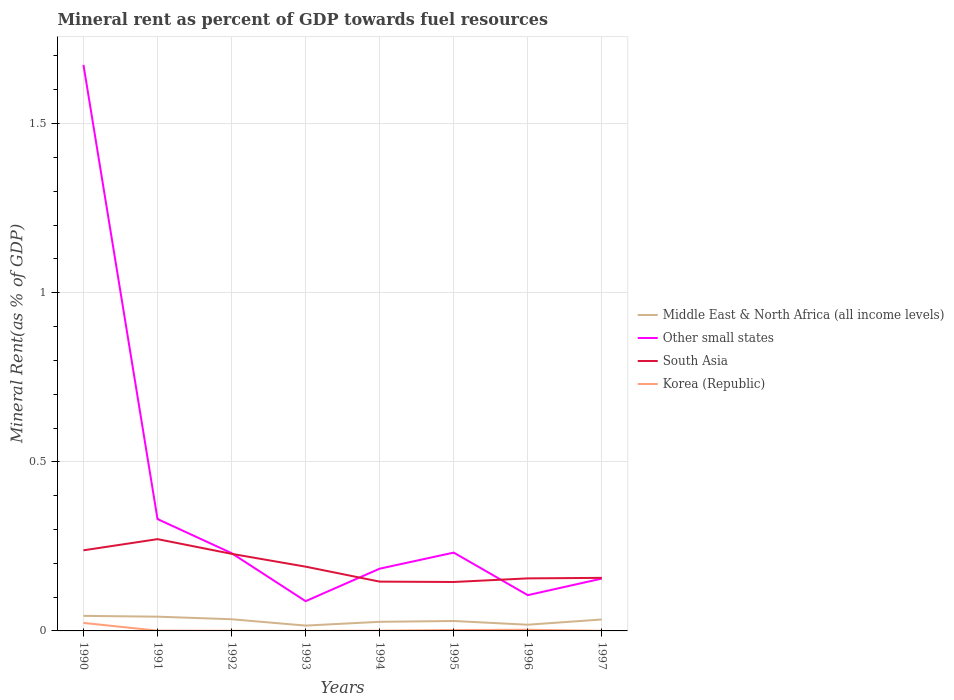Does the line corresponding to Korea (Republic) intersect with the line corresponding to Other small states?
Give a very brief answer. No. Across all years, what is the maximum mineral rent in Other small states?
Offer a very short reply. 0.09. What is the total mineral rent in South Asia in the graph?
Your response must be concise. 0.04. What is the difference between the highest and the second highest mineral rent in Korea (Republic)?
Ensure brevity in your answer.  0.02. What is the difference between the highest and the lowest mineral rent in South Asia?
Give a very brief answer. 3. Does the graph contain grids?
Give a very brief answer. Yes. How are the legend labels stacked?
Give a very brief answer. Vertical. What is the title of the graph?
Your response must be concise. Mineral rent as percent of GDP towards fuel resources. Does "European Union" appear as one of the legend labels in the graph?
Your answer should be very brief. No. What is the label or title of the Y-axis?
Provide a succinct answer. Mineral Rent(as % of GDP). What is the Mineral Rent(as % of GDP) in Middle East & North Africa (all income levels) in 1990?
Offer a terse response. 0.04. What is the Mineral Rent(as % of GDP) of Other small states in 1990?
Your response must be concise. 1.67. What is the Mineral Rent(as % of GDP) of South Asia in 1990?
Keep it short and to the point. 0.24. What is the Mineral Rent(as % of GDP) of Korea (Republic) in 1990?
Your answer should be compact. 0.02. What is the Mineral Rent(as % of GDP) of Middle East & North Africa (all income levels) in 1991?
Your answer should be very brief. 0.04. What is the Mineral Rent(as % of GDP) in Other small states in 1991?
Ensure brevity in your answer.  0.33. What is the Mineral Rent(as % of GDP) of South Asia in 1991?
Make the answer very short. 0.27. What is the Mineral Rent(as % of GDP) in Korea (Republic) in 1991?
Ensure brevity in your answer.  0. What is the Mineral Rent(as % of GDP) in Middle East & North Africa (all income levels) in 1992?
Provide a short and direct response. 0.03. What is the Mineral Rent(as % of GDP) in Other small states in 1992?
Your response must be concise. 0.23. What is the Mineral Rent(as % of GDP) of South Asia in 1992?
Provide a short and direct response. 0.23. What is the Mineral Rent(as % of GDP) in Korea (Republic) in 1992?
Give a very brief answer. 0. What is the Mineral Rent(as % of GDP) in Middle East & North Africa (all income levels) in 1993?
Your response must be concise. 0.02. What is the Mineral Rent(as % of GDP) in Other small states in 1993?
Provide a short and direct response. 0.09. What is the Mineral Rent(as % of GDP) in South Asia in 1993?
Make the answer very short. 0.19. What is the Mineral Rent(as % of GDP) of Korea (Republic) in 1993?
Ensure brevity in your answer.  0. What is the Mineral Rent(as % of GDP) in Middle East & North Africa (all income levels) in 1994?
Keep it short and to the point. 0.03. What is the Mineral Rent(as % of GDP) in Other small states in 1994?
Provide a short and direct response. 0.18. What is the Mineral Rent(as % of GDP) in South Asia in 1994?
Provide a succinct answer. 0.15. What is the Mineral Rent(as % of GDP) in Korea (Republic) in 1994?
Provide a short and direct response. 0. What is the Mineral Rent(as % of GDP) in Middle East & North Africa (all income levels) in 1995?
Ensure brevity in your answer.  0.03. What is the Mineral Rent(as % of GDP) in Other small states in 1995?
Your answer should be compact. 0.23. What is the Mineral Rent(as % of GDP) of South Asia in 1995?
Make the answer very short. 0.14. What is the Mineral Rent(as % of GDP) of Korea (Republic) in 1995?
Provide a succinct answer. 0. What is the Mineral Rent(as % of GDP) in Middle East & North Africa (all income levels) in 1996?
Your response must be concise. 0.02. What is the Mineral Rent(as % of GDP) of Other small states in 1996?
Offer a terse response. 0.11. What is the Mineral Rent(as % of GDP) in South Asia in 1996?
Your answer should be very brief. 0.16. What is the Mineral Rent(as % of GDP) in Korea (Republic) in 1996?
Ensure brevity in your answer.  0. What is the Mineral Rent(as % of GDP) of Middle East & North Africa (all income levels) in 1997?
Your response must be concise. 0.03. What is the Mineral Rent(as % of GDP) in Other small states in 1997?
Offer a very short reply. 0.15. What is the Mineral Rent(as % of GDP) in South Asia in 1997?
Keep it short and to the point. 0.16. What is the Mineral Rent(as % of GDP) of Korea (Republic) in 1997?
Your answer should be very brief. 0. Across all years, what is the maximum Mineral Rent(as % of GDP) of Middle East & North Africa (all income levels)?
Keep it short and to the point. 0.04. Across all years, what is the maximum Mineral Rent(as % of GDP) in Other small states?
Your response must be concise. 1.67. Across all years, what is the maximum Mineral Rent(as % of GDP) in South Asia?
Your response must be concise. 0.27. Across all years, what is the maximum Mineral Rent(as % of GDP) in Korea (Republic)?
Offer a terse response. 0.02. Across all years, what is the minimum Mineral Rent(as % of GDP) of Middle East & North Africa (all income levels)?
Your response must be concise. 0.02. Across all years, what is the minimum Mineral Rent(as % of GDP) in Other small states?
Provide a short and direct response. 0.09. Across all years, what is the minimum Mineral Rent(as % of GDP) in South Asia?
Make the answer very short. 0.14. Across all years, what is the minimum Mineral Rent(as % of GDP) in Korea (Republic)?
Provide a short and direct response. 0. What is the total Mineral Rent(as % of GDP) in Middle East & North Africa (all income levels) in the graph?
Offer a terse response. 0.25. What is the total Mineral Rent(as % of GDP) of Other small states in the graph?
Make the answer very short. 3. What is the total Mineral Rent(as % of GDP) in South Asia in the graph?
Give a very brief answer. 1.53. What is the total Mineral Rent(as % of GDP) of Korea (Republic) in the graph?
Your answer should be very brief. 0.03. What is the difference between the Mineral Rent(as % of GDP) of Middle East & North Africa (all income levels) in 1990 and that in 1991?
Ensure brevity in your answer.  0. What is the difference between the Mineral Rent(as % of GDP) in Other small states in 1990 and that in 1991?
Make the answer very short. 1.34. What is the difference between the Mineral Rent(as % of GDP) of South Asia in 1990 and that in 1991?
Your response must be concise. -0.03. What is the difference between the Mineral Rent(as % of GDP) of Korea (Republic) in 1990 and that in 1991?
Ensure brevity in your answer.  0.02. What is the difference between the Mineral Rent(as % of GDP) of Other small states in 1990 and that in 1992?
Offer a very short reply. 1.44. What is the difference between the Mineral Rent(as % of GDP) in South Asia in 1990 and that in 1992?
Your response must be concise. 0.01. What is the difference between the Mineral Rent(as % of GDP) in Korea (Republic) in 1990 and that in 1992?
Offer a terse response. 0.02. What is the difference between the Mineral Rent(as % of GDP) of Middle East & North Africa (all income levels) in 1990 and that in 1993?
Give a very brief answer. 0.03. What is the difference between the Mineral Rent(as % of GDP) in Other small states in 1990 and that in 1993?
Provide a short and direct response. 1.59. What is the difference between the Mineral Rent(as % of GDP) of South Asia in 1990 and that in 1993?
Provide a succinct answer. 0.05. What is the difference between the Mineral Rent(as % of GDP) in Korea (Republic) in 1990 and that in 1993?
Make the answer very short. 0.02. What is the difference between the Mineral Rent(as % of GDP) of Middle East & North Africa (all income levels) in 1990 and that in 1994?
Offer a very short reply. 0.02. What is the difference between the Mineral Rent(as % of GDP) of Other small states in 1990 and that in 1994?
Provide a short and direct response. 1.49. What is the difference between the Mineral Rent(as % of GDP) of South Asia in 1990 and that in 1994?
Offer a terse response. 0.09. What is the difference between the Mineral Rent(as % of GDP) in Korea (Republic) in 1990 and that in 1994?
Make the answer very short. 0.02. What is the difference between the Mineral Rent(as % of GDP) of Middle East & North Africa (all income levels) in 1990 and that in 1995?
Ensure brevity in your answer.  0.02. What is the difference between the Mineral Rent(as % of GDP) of Other small states in 1990 and that in 1995?
Your answer should be compact. 1.44. What is the difference between the Mineral Rent(as % of GDP) in South Asia in 1990 and that in 1995?
Your answer should be compact. 0.09. What is the difference between the Mineral Rent(as % of GDP) in Korea (Republic) in 1990 and that in 1995?
Provide a short and direct response. 0.02. What is the difference between the Mineral Rent(as % of GDP) of Middle East & North Africa (all income levels) in 1990 and that in 1996?
Your answer should be compact. 0.03. What is the difference between the Mineral Rent(as % of GDP) of Other small states in 1990 and that in 1996?
Your answer should be compact. 1.57. What is the difference between the Mineral Rent(as % of GDP) in South Asia in 1990 and that in 1996?
Make the answer very short. 0.08. What is the difference between the Mineral Rent(as % of GDP) in Korea (Republic) in 1990 and that in 1996?
Provide a short and direct response. 0.02. What is the difference between the Mineral Rent(as % of GDP) in Middle East & North Africa (all income levels) in 1990 and that in 1997?
Make the answer very short. 0.01. What is the difference between the Mineral Rent(as % of GDP) of Other small states in 1990 and that in 1997?
Give a very brief answer. 1.52. What is the difference between the Mineral Rent(as % of GDP) of South Asia in 1990 and that in 1997?
Your answer should be very brief. 0.08. What is the difference between the Mineral Rent(as % of GDP) of Korea (Republic) in 1990 and that in 1997?
Your response must be concise. 0.02. What is the difference between the Mineral Rent(as % of GDP) of Middle East & North Africa (all income levels) in 1991 and that in 1992?
Provide a short and direct response. 0.01. What is the difference between the Mineral Rent(as % of GDP) in Other small states in 1991 and that in 1992?
Offer a terse response. 0.1. What is the difference between the Mineral Rent(as % of GDP) of South Asia in 1991 and that in 1992?
Offer a terse response. 0.04. What is the difference between the Mineral Rent(as % of GDP) of Middle East & North Africa (all income levels) in 1991 and that in 1993?
Offer a terse response. 0.03. What is the difference between the Mineral Rent(as % of GDP) of Other small states in 1991 and that in 1993?
Your response must be concise. 0.24. What is the difference between the Mineral Rent(as % of GDP) of South Asia in 1991 and that in 1993?
Your answer should be very brief. 0.08. What is the difference between the Mineral Rent(as % of GDP) of Korea (Republic) in 1991 and that in 1993?
Your response must be concise. 0. What is the difference between the Mineral Rent(as % of GDP) in Middle East & North Africa (all income levels) in 1991 and that in 1994?
Give a very brief answer. 0.02. What is the difference between the Mineral Rent(as % of GDP) in Other small states in 1991 and that in 1994?
Your answer should be compact. 0.15. What is the difference between the Mineral Rent(as % of GDP) in South Asia in 1991 and that in 1994?
Offer a terse response. 0.13. What is the difference between the Mineral Rent(as % of GDP) in Middle East & North Africa (all income levels) in 1991 and that in 1995?
Keep it short and to the point. 0.01. What is the difference between the Mineral Rent(as % of GDP) in Other small states in 1991 and that in 1995?
Your answer should be compact. 0.1. What is the difference between the Mineral Rent(as % of GDP) in South Asia in 1991 and that in 1995?
Your answer should be compact. 0.13. What is the difference between the Mineral Rent(as % of GDP) of Korea (Republic) in 1991 and that in 1995?
Your answer should be very brief. -0. What is the difference between the Mineral Rent(as % of GDP) of Middle East & North Africa (all income levels) in 1991 and that in 1996?
Give a very brief answer. 0.02. What is the difference between the Mineral Rent(as % of GDP) in Other small states in 1991 and that in 1996?
Offer a very short reply. 0.23. What is the difference between the Mineral Rent(as % of GDP) of South Asia in 1991 and that in 1996?
Give a very brief answer. 0.12. What is the difference between the Mineral Rent(as % of GDP) in Korea (Republic) in 1991 and that in 1996?
Provide a succinct answer. -0. What is the difference between the Mineral Rent(as % of GDP) in Middle East & North Africa (all income levels) in 1991 and that in 1997?
Keep it short and to the point. 0.01. What is the difference between the Mineral Rent(as % of GDP) in Other small states in 1991 and that in 1997?
Your answer should be very brief. 0.18. What is the difference between the Mineral Rent(as % of GDP) in South Asia in 1991 and that in 1997?
Provide a short and direct response. 0.11. What is the difference between the Mineral Rent(as % of GDP) in Korea (Republic) in 1991 and that in 1997?
Your response must be concise. 0. What is the difference between the Mineral Rent(as % of GDP) of Middle East & North Africa (all income levels) in 1992 and that in 1993?
Give a very brief answer. 0.02. What is the difference between the Mineral Rent(as % of GDP) of Other small states in 1992 and that in 1993?
Offer a terse response. 0.14. What is the difference between the Mineral Rent(as % of GDP) of South Asia in 1992 and that in 1993?
Your response must be concise. 0.04. What is the difference between the Mineral Rent(as % of GDP) of Middle East & North Africa (all income levels) in 1992 and that in 1994?
Make the answer very short. 0.01. What is the difference between the Mineral Rent(as % of GDP) in Other small states in 1992 and that in 1994?
Your answer should be compact. 0.05. What is the difference between the Mineral Rent(as % of GDP) of South Asia in 1992 and that in 1994?
Your answer should be very brief. 0.08. What is the difference between the Mineral Rent(as % of GDP) in Korea (Republic) in 1992 and that in 1994?
Your response must be concise. -0. What is the difference between the Mineral Rent(as % of GDP) in Middle East & North Africa (all income levels) in 1992 and that in 1995?
Give a very brief answer. 0.01. What is the difference between the Mineral Rent(as % of GDP) in Other small states in 1992 and that in 1995?
Give a very brief answer. -0. What is the difference between the Mineral Rent(as % of GDP) in South Asia in 1992 and that in 1995?
Make the answer very short. 0.08. What is the difference between the Mineral Rent(as % of GDP) in Korea (Republic) in 1992 and that in 1995?
Offer a terse response. -0. What is the difference between the Mineral Rent(as % of GDP) in Middle East & North Africa (all income levels) in 1992 and that in 1996?
Give a very brief answer. 0.02. What is the difference between the Mineral Rent(as % of GDP) of Other small states in 1992 and that in 1996?
Provide a succinct answer. 0.12. What is the difference between the Mineral Rent(as % of GDP) in South Asia in 1992 and that in 1996?
Provide a short and direct response. 0.07. What is the difference between the Mineral Rent(as % of GDP) of Korea (Republic) in 1992 and that in 1996?
Ensure brevity in your answer.  -0. What is the difference between the Mineral Rent(as % of GDP) in Middle East & North Africa (all income levels) in 1992 and that in 1997?
Make the answer very short. 0. What is the difference between the Mineral Rent(as % of GDP) in Other small states in 1992 and that in 1997?
Provide a succinct answer. 0.08. What is the difference between the Mineral Rent(as % of GDP) in South Asia in 1992 and that in 1997?
Provide a short and direct response. 0.07. What is the difference between the Mineral Rent(as % of GDP) in Korea (Republic) in 1992 and that in 1997?
Keep it short and to the point. 0. What is the difference between the Mineral Rent(as % of GDP) in Middle East & North Africa (all income levels) in 1993 and that in 1994?
Provide a short and direct response. -0.01. What is the difference between the Mineral Rent(as % of GDP) of Other small states in 1993 and that in 1994?
Your answer should be very brief. -0.1. What is the difference between the Mineral Rent(as % of GDP) in South Asia in 1993 and that in 1994?
Provide a short and direct response. 0.04. What is the difference between the Mineral Rent(as % of GDP) in Korea (Republic) in 1993 and that in 1994?
Make the answer very short. -0. What is the difference between the Mineral Rent(as % of GDP) of Middle East & North Africa (all income levels) in 1993 and that in 1995?
Your answer should be compact. -0.01. What is the difference between the Mineral Rent(as % of GDP) in Other small states in 1993 and that in 1995?
Offer a terse response. -0.14. What is the difference between the Mineral Rent(as % of GDP) in South Asia in 1993 and that in 1995?
Give a very brief answer. 0.05. What is the difference between the Mineral Rent(as % of GDP) in Korea (Republic) in 1993 and that in 1995?
Offer a terse response. -0. What is the difference between the Mineral Rent(as % of GDP) in Middle East & North Africa (all income levels) in 1993 and that in 1996?
Offer a very short reply. -0. What is the difference between the Mineral Rent(as % of GDP) in Other small states in 1993 and that in 1996?
Your answer should be compact. -0.02. What is the difference between the Mineral Rent(as % of GDP) of South Asia in 1993 and that in 1996?
Keep it short and to the point. 0.03. What is the difference between the Mineral Rent(as % of GDP) in Korea (Republic) in 1993 and that in 1996?
Provide a short and direct response. -0. What is the difference between the Mineral Rent(as % of GDP) in Middle East & North Africa (all income levels) in 1993 and that in 1997?
Make the answer very short. -0.02. What is the difference between the Mineral Rent(as % of GDP) of Other small states in 1993 and that in 1997?
Keep it short and to the point. -0.07. What is the difference between the Mineral Rent(as % of GDP) in South Asia in 1993 and that in 1997?
Offer a terse response. 0.03. What is the difference between the Mineral Rent(as % of GDP) of Korea (Republic) in 1993 and that in 1997?
Give a very brief answer. -0. What is the difference between the Mineral Rent(as % of GDP) of Middle East & North Africa (all income levels) in 1994 and that in 1995?
Offer a very short reply. -0. What is the difference between the Mineral Rent(as % of GDP) in Other small states in 1994 and that in 1995?
Make the answer very short. -0.05. What is the difference between the Mineral Rent(as % of GDP) in South Asia in 1994 and that in 1995?
Offer a terse response. 0. What is the difference between the Mineral Rent(as % of GDP) in Korea (Republic) in 1994 and that in 1995?
Offer a terse response. -0. What is the difference between the Mineral Rent(as % of GDP) of Middle East & North Africa (all income levels) in 1994 and that in 1996?
Ensure brevity in your answer.  0.01. What is the difference between the Mineral Rent(as % of GDP) of Other small states in 1994 and that in 1996?
Offer a very short reply. 0.08. What is the difference between the Mineral Rent(as % of GDP) in South Asia in 1994 and that in 1996?
Provide a short and direct response. -0.01. What is the difference between the Mineral Rent(as % of GDP) in Korea (Republic) in 1994 and that in 1996?
Make the answer very short. -0. What is the difference between the Mineral Rent(as % of GDP) of Middle East & North Africa (all income levels) in 1994 and that in 1997?
Make the answer very short. -0.01. What is the difference between the Mineral Rent(as % of GDP) in Other small states in 1994 and that in 1997?
Offer a terse response. 0.03. What is the difference between the Mineral Rent(as % of GDP) of South Asia in 1994 and that in 1997?
Your answer should be very brief. -0.01. What is the difference between the Mineral Rent(as % of GDP) in Korea (Republic) in 1994 and that in 1997?
Offer a terse response. 0. What is the difference between the Mineral Rent(as % of GDP) in Middle East & North Africa (all income levels) in 1995 and that in 1996?
Make the answer very short. 0.01. What is the difference between the Mineral Rent(as % of GDP) in Other small states in 1995 and that in 1996?
Offer a very short reply. 0.13. What is the difference between the Mineral Rent(as % of GDP) in South Asia in 1995 and that in 1996?
Make the answer very short. -0.01. What is the difference between the Mineral Rent(as % of GDP) of Korea (Republic) in 1995 and that in 1996?
Provide a succinct answer. -0. What is the difference between the Mineral Rent(as % of GDP) in Middle East & North Africa (all income levels) in 1995 and that in 1997?
Your answer should be very brief. -0. What is the difference between the Mineral Rent(as % of GDP) in Other small states in 1995 and that in 1997?
Offer a terse response. 0.08. What is the difference between the Mineral Rent(as % of GDP) in South Asia in 1995 and that in 1997?
Your answer should be very brief. -0.01. What is the difference between the Mineral Rent(as % of GDP) in Korea (Republic) in 1995 and that in 1997?
Your response must be concise. 0. What is the difference between the Mineral Rent(as % of GDP) in Middle East & North Africa (all income levels) in 1996 and that in 1997?
Your answer should be very brief. -0.02. What is the difference between the Mineral Rent(as % of GDP) in Other small states in 1996 and that in 1997?
Provide a short and direct response. -0.05. What is the difference between the Mineral Rent(as % of GDP) in South Asia in 1996 and that in 1997?
Provide a succinct answer. -0. What is the difference between the Mineral Rent(as % of GDP) of Korea (Republic) in 1996 and that in 1997?
Your response must be concise. 0. What is the difference between the Mineral Rent(as % of GDP) in Middle East & North Africa (all income levels) in 1990 and the Mineral Rent(as % of GDP) in Other small states in 1991?
Provide a succinct answer. -0.29. What is the difference between the Mineral Rent(as % of GDP) in Middle East & North Africa (all income levels) in 1990 and the Mineral Rent(as % of GDP) in South Asia in 1991?
Your answer should be compact. -0.23. What is the difference between the Mineral Rent(as % of GDP) in Middle East & North Africa (all income levels) in 1990 and the Mineral Rent(as % of GDP) in Korea (Republic) in 1991?
Ensure brevity in your answer.  0.04. What is the difference between the Mineral Rent(as % of GDP) of Other small states in 1990 and the Mineral Rent(as % of GDP) of South Asia in 1991?
Provide a short and direct response. 1.4. What is the difference between the Mineral Rent(as % of GDP) in Other small states in 1990 and the Mineral Rent(as % of GDP) in Korea (Republic) in 1991?
Make the answer very short. 1.67. What is the difference between the Mineral Rent(as % of GDP) in South Asia in 1990 and the Mineral Rent(as % of GDP) in Korea (Republic) in 1991?
Provide a succinct answer. 0.24. What is the difference between the Mineral Rent(as % of GDP) of Middle East & North Africa (all income levels) in 1990 and the Mineral Rent(as % of GDP) of Other small states in 1992?
Give a very brief answer. -0.19. What is the difference between the Mineral Rent(as % of GDP) in Middle East & North Africa (all income levels) in 1990 and the Mineral Rent(as % of GDP) in South Asia in 1992?
Provide a succinct answer. -0.18. What is the difference between the Mineral Rent(as % of GDP) of Middle East & North Africa (all income levels) in 1990 and the Mineral Rent(as % of GDP) of Korea (Republic) in 1992?
Provide a succinct answer. 0.04. What is the difference between the Mineral Rent(as % of GDP) in Other small states in 1990 and the Mineral Rent(as % of GDP) in South Asia in 1992?
Give a very brief answer. 1.45. What is the difference between the Mineral Rent(as % of GDP) of Other small states in 1990 and the Mineral Rent(as % of GDP) of Korea (Republic) in 1992?
Provide a short and direct response. 1.67. What is the difference between the Mineral Rent(as % of GDP) in South Asia in 1990 and the Mineral Rent(as % of GDP) in Korea (Republic) in 1992?
Ensure brevity in your answer.  0.24. What is the difference between the Mineral Rent(as % of GDP) of Middle East & North Africa (all income levels) in 1990 and the Mineral Rent(as % of GDP) of Other small states in 1993?
Offer a terse response. -0.04. What is the difference between the Mineral Rent(as % of GDP) of Middle East & North Africa (all income levels) in 1990 and the Mineral Rent(as % of GDP) of South Asia in 1993?
Your response must be concise. -0.15. What is the difference between the Mineral Rent(as % of GDP) in Middle East & North Africa (all income levels) in 1990 and the Mineral Rent(as % of GDP) in Korea (Republic) in 1993?
Ensure brevity in your answer.  0.04. What is the difference between the Mineral Rent(as % of GDP) of Other small states in 1990 and the Mineral Rent(as % of GDP) of South Asia in 1993?
Your answer should be very brief. 1.48. What is the difference between the Mineral Rent(as % of GDP) in Other small states in 1990 and the Mineral Rent(as % of GDP) in Korea (Republic) in 1993?
Provide a short and direct response. 1.67. What is the difference between the Mineral Rent(as % of GDP) of South Asia in 1990 and the Mineral Rent(as % of GDP) of Korea (Republic) in 1993?
Your answer should be very brief. 0.24. What is the difference between the Mineral Rent(as % of GDP) in Middle East & North Africa (all income levels) in 1990 and the Mineral Rent(as % of GDP) in Other small states in 1994?
Your answer should be compact. -0.14. What is the difference between the Mineral Rent(as % of GDP) of Middle East & North Africa (all income levels) in 1990 and the Mineral Rent(as % of GDP) of South Asia in 1994?
Provide a succinct answer. -0.1. What is the difference between the Mineral Rent(as % of GDP) in Middle East & North Africa (all income levels) in 1990 and the Mineral Rent(as % of GDP) in Korea (Republic) in 1994?
Your answer should be compact. 0.04. What is the difference between the Mineral Rent(as % of GDP) of Other small states in 1990 and the Mineral Rent(as % of GDP) of South Asia in 1994?
Keep it short and to the point. 1.53. What is the difference between the Mineral Rent(as % of GDP) in Other small states in 1990 and the Mineral Rent(as % of GDP) in Korea (Republic) in 1994?
Provide a short and direct response. 1.67. What is the difference between the Mineral Rent(as % of GDP) in South Asia in 1990 and the Mineral Rent(as % of GDP) in Korea (Republic) in 1994?
Keep it short and to the point. 0.24. What is the difference between the Mineral Rent(as % of GDP) of Middle East & North Africa (all income levels) in 1990 and the Mineral Rent(as % of GDP) of Other small states in 1995?
Give a very brief answer. -0.19. What is the difference between the Mineral Rent(as % of GDP) in Middle East & North Africa (all income levels) in 1990 and the Mineral Rent(as % of GDP) in South Asia in 1995?
Provide a succinct answer. -0.1. What is the difference between the Mineral Rent(as % of GDP) of Middle East & North Africa (all income levels) in 1990 and the Mineral Rent(as % of GDP) of Korea (Republic) in 1995?
Offer a terse response. 0.04. What is the difference between the Mineral Rent(as % of GDP) in Other small states in 1990 and the Mineral Rent(as % of GDP) in South Asia in 1995?
Provide a succinct answer. 1.53. What is the difference between the Mineral Rent(as % of GDP) in Other small states in 1990 and the Mineral Rent(as % of GDP) in Korea (Republic) in 1995?
Make the answer very short. 1.67. What is the difference between the Mineral Rent(as % of GDP) in South Asia in 1990 and the Mineral Rent(as % of GDP) in Korea (Republic) in 1995?
Your answer should be very brief. 0.24. What is the difference between the Mineral Rent(as % of GDP) of Middle East & North Africa (all income levels) in 1990 and the Mineral Rent(as % of GDP) of Other small states in 1996?
Provide a succinct answer. -0.06. What is the difference between the Mineral Rent(as % of GDP) of Middle East & North Africa (all income levels) in 1990 and the Mineral Rent(as % of GDP) of South Asia in 1996?
Your answer should be very brief. -0.11. What is the difference between the Mineral Rent(as % of GDP) of Middle East & North Africa (all income levels) in 1990 and the Mineral Rent(as % of GDP) of Korea (Republic) in 1996?
Your answer should be very brief. 0.04. What is the difference between the Mineral Rent(as % of GDP) of Other small states in 1990 and the Mineral Rent(as % of GDP) of South Asia in 1996?
Ensure brevity in your answer.  1.52. What is the difference between the Mineral Rent(as % of GDP) in Other small states in 1990 and the Mineral Rent(as % of GDP) in Korea (Republic) in 1996?
Offer a very short reply. 1.67. What is the difference between the Mineral Rent(as % of GDP) in South Asia in 1990 and the Mineral Rent(as % of GDP) in Korea (Republic) in 1996?
Give a very brief answer. 0.23. What is the difference between the Mineral Rent(as % of GDP) in Middle East & North Africa (all income levels) in 1990 and the Mineral Rent(as % of GDP) in Other small states in 1997?
Your response must be concise. -0.11. What is the difference between the Mineral Rent(as % of GDP) of Middle East & North Africa (all income levels) in 1990 and the Mineral Rent(as % of GDP) of South Asia in 1997?
Offer a very short reply. -0.11. What is the difference between the Mineral Rent(as % of GDP) in Middle East & North Africa (all income levels) in 1990 and the Mineral Rent(as % of GDP) in Korea (Republic) in 1997?
Give a very brief answer. 0.04. What is the difference between the Mineral Rent(as % of GDP) in Other small states in 1990 and the Mineral Rent(as % of GDP) in South Asia in 1997?
Provide a succinct answer. 1.52. What is the difference between the Mineral Rent(as % of GDP) of Other small states in 1990 and the Mineral Rent(as % of GDP) of Korea (Republic) in 1997?
Give a very brief answer. 1.67. What is the difference between the Mineral Rent(as % of GDP) of South Asia in 1990 and the Mineral Rent(as % of GDP) of Korea (Republic) in 1997?
Make the answer very short. 0.24. What is the difference between the Mineral Rent(as % of GDP) of Middle East & North Africa (all income levels) in 1991 and the Mineral Rent(as % of GDP) of Other small states in 1992?
Provide a short and direct response. -0.19. What is the difference between the Mineral Rent(as % of GDP) of Middle East & North Africa (all income levels) in 1991 and the Mineral Rent(as % of GDP) of South Asia in 1992?
Your response must be concise. -0.19. What is the difference between the Mineral Rent(as % of GDP) of Middle East & North Africa (all income levels) in 1991 and the Mineral Rent(as % of GDP) of Korea (Republic) in 1992?
Ensure brevity in your answer.  0.04. What is the difference between the Mineral Rent(as % of GDP) of Other small states in 1991 and the Mineral Rent(as % of GDP) of South Asia in 1992?
Provide a succinct answer. 0.1. What is the difference between the Mineral Rent(as % of GDP) in Other small states in 1991 and the Mineral Rent(as % of GDP) in Korea (Republic) in 1992?
Offer a very short reply. 0.33. What is the difference between the Mineral Rent(as % of GDP) in South Asia in 1991 and the Mineral Rent(as % of GDP) in Korea (Republic) in 1992?
Provide a succinct answer. 0.27. What is the difference between the Mineral Rent(as % of GDP) of Middle East & North Africa (all income levels) in 1991 and the Mineral Rent(as % of GDP) of Other small states in 1993?
Keep it short and to the point. -0.05. What is the difference between the Mineral Rent(as % of GDP) of Middle East & North Africa (all income levels) in 1991 and the Mineral Rent(as % of GDP) of South Asia in 1993?
Provide a short and direct response. -0.15. What is the difference between the Mineral Rent(as % of GDP) in Middle East & North Africa (all income levels) in 1991 and the Mineral Rent(as % of GDP) in Korea (Republic) in 1993?
Offer a very short reply. 0.04. What is the difference between the Mineral Rent(as % of GDP) of Other small states in 1991 and the Mineral Rent(as % of GDP) of South Asia in 1993?
Give a very brief answer. 0.14. What is the difference between the Mineral Rent(as % of GDP) in Other small states in 1991 and the Mineral Rent(as % of GDP) in Korea (Republic) in 1993?
Your answer should be very brief. 0.33. What is the difference between the Mineral Rent(as % of GDP) in South Asia in 1991 and the Mineral Rent(as % of GDP) in Korea (Republic) in 1993?
Ensure brevity in your answer.  0.27. What is the difference between the Mineral Rent(as % of GDP) of Middle East & North Africa (all income levels) in 1991 and the Mineral Rent(as % of GDP) of Other small states in 1994?
Your answer should be very brief. -0.14. What is the difference between the Mineral Rent(as % of GDP) of Middle East & North Africa (all income levels) in 1991 and the Mineral Rent(as % of GDP) of South Asia in 1994?
Your answer should be compact. -0.1. What is the difference between the Mineral Rent(as % of GDP) of Middle East & North Africa (all income levels) in 1991 and the Mineral Rent(as % of GDP) of Korea (Republic) in 1994?
Provide a succinct answer. 0.04. What is the difference between the Mineral Rent(as % of GDP) of Other small states in 1991 and the Mineral Rent(as % of GDP) of South Asia in 1994?
Your answer should be compact. 0.18. What is the difference between the Mineral Rent(as % of GDP) in Other small states in 1991 and the Mineral Rent(as % of GDP) in Korea (Republic) in 1994?
Your answer should be compact. 0.33. What is the difference between the Mineral Rent(as % of GDP) in South Asia in 1991 and the Mineral Rent(as % of GDP) in Korea (Republic) in 1994?
Offer a very short reply. 0.27. What is the difference between the Mineral Rent(as % of GDP) of Middle East & North Africa (all income levels) in 1991 and the Mineral Rent(as % of GDP) of Other small states in 1995?
Ensure brevity in your answer.  -0.19. What is the difference between the Mineral Rent(as % of GDP) in Middle East & North Africa (all income levels) in 1991 and the Mineral Rent(as % of GDP) in South Asia in 1995?
Ensure brevity in your answer.  -0.1. What is the difference between the Mineral Rent(as % of GDP) in Middle East & North Africa (all income levels) in 1991 and the Mineral Rent(as % of GDP) in Korea (Republic) in 1995?
Your response must be concise. 0.04. What is the difference between the Mineral Rent(as % of GDP) in Other small states in 1991 and the Mineral Rent(as % of GDP) in South Asia in 1995?
Your response must be concise. 0.19. What is the difference between the Mineral Rent(as % of GDP) in Other small states in 1991 and the Mineral Rent(as % of GDP) in Korea (Republic) in 1995?
Your answer should be compact. 0.33. What is the difference between the Mineral Rent(as % of GDP) of South Asia in 1991 and the Mineral Rent(as % of GDP) of Korea (Republic) in 1995?
Your answer should be very brief. 0.27. What is the difference between the Mineral Rent(as % of GDP) in Middle East & North Africa (all income levels) in 1991 and the Mineral Rent(as % of GDP) in Other small states in 1996?
Offer a very short reply. -0.06. What is the difference between the Mineral Rent(as % of GDP) in Middle East & North Africa (all income levels) in 1991 and the Mineral Rent(as % of GDP) in South Asia in 1996?
Offer a terse response. -0.11. What is the difference between the Mineral Rent(as % of GDP) in Middle East & North Africa (all income levels) in 1991 and the Mineral Rent(as % of GDP) in Korea (Republic) in 1996?
Offer a terse response. 0.04. What is the difference between the Mineral Rent(as % of GDP) in Other small states in 1991 and the Mineral Rent(as % of GDP) in South Asia in 1996?
Your answer should be compact. 0.18. What is the difference between the Mineral Rent(as % of GDP) of Other small states in 1991 and the Mineral Rent(as % of GDP) of Korea (Republic) in 1996?
Provide a succinct answer. 0.33. What is the difference between the Mineral Rent(as % of GDP) of South Asia in 1991 and the Mineral Rent(as % of GDP) of Korea (Republic) in 1996?
Your answer should be very brief. 0.27. What is the difference between the Mineral Rent(as % of GDP) in Middle East & North Africa (all income levels) in 1991 and the Mineral Rent(as % of GDP) in Other small states in 1997?
Provide a succinct answer. -0.11. What is the difference between the Mineral Rent(as % of GDP) of Middle East & North Africa (all income levels) in 1991 and the Mineral Rent(as % of GDP) of South Asia in 1997?
Provide a short and direct response. -0.11. What is the difference between the Mineral Rent(as % of GDP) in Middle East & North Africa (all income levels) in 1991 and the Mineral Rent(as % of GDP) in Korea (Republic) in 1997?
Give a very brief answer. 0.04. What is the difference between the Mineral Rent(as % of GDP) in Other small states in 1991 and the Mineral Rent(as % of GDP) in South Asia in 1997?
Offer a terse response. 0.17. What is the difference between the Mineral Rent(as % of GDP) of Other small states in 1991 and the Mineral Rent(as % of GDP) of Korea (Republic) in 1997?
Make the answer very short. 0.33. What is the difference between the Mineral Rent(as % of GDP) of South Asia in 1991 and the Mineral Rent(as % of GDP) of Korea (Republic) in 1997?
Offer a very short reply. 0.27. What is the difference between the Mineral Rent(as % of GDP) of Middle East & North Africa (all income levels) in 1992 and the Mineral Rent(as % of GDP) of Other small states in 1993?
Provide a succinct answer. -0.05. What is the difference between the Mineral Rent(as % of GDP) in Middle East & North Africa (all income levels) in 1992 and the Mineral Rent(as % of GDP) in South Asia in 1993?
Make the answer very short. -0.16. What is the difference between the Mineral Rent(as % of GDP) in Middle East & North Africa (all income levels) in 1992 and the Mineral Rent(as % of GDP) in Korea (Republic) in 1993?
Offer a very short reply. 0.03. What is the difference between the Mineral Rent(as % of GDP) in Other small states in 1992 and the Mineral Rent(as % of GDP) in South Asia in 1993?
Provide a succinct answer. 0.04. What is the difference between the Mineral Rent(as % of GDP) in Other small states in 1992 and the Mineral Rent(as % of GDP) in Korea (Republic) in 1993?
Provide a short and direct response. 0.23. What is the difference between the Mineral Rent(as % of GDP) in South Asia in 1992 and the Mineral Rent(as % of GDP) in Korea (Republic) in 1993?
Make the answer very short. 0.23. What is the difference between the Mineral Rent(as % of GDP) of Middle East & North Africa (all income levels) in 1992 and the Mineral Rent(as % of GDP) of Other small states in 1994?
Offer a terse response. -0.15. What is the difference between the Mineral Rent(as % of GDP) of Middle East & North Africa (all income levels) in 1992 and the Mineral Rent(as % of GDP) of South Asia in 1994?
Your answer should be compact. -0.11. What is the difference between the Mineral Rent(as % of GDP) of Middle East & North Africa (all income levels) in 1992 and the Mineral Rent(as % of GDP) of Korea (Republic) in 1994?
Make the answer very short. 0.03. What is the difference between the Mineral Rent(as % of GDP) in Other small states in 1992 and the Mineral Rent(as % of GDP) in South Asia in 1994?
Provide a short and direct response. 0.08. What is the difference between the Mineral Rent(as % of GDP) in Other small states in 1992 and the Mineral Rent(as % of GDP) in Korea (Republic) in 1994?
Your answer should be compact. 0.23. What is the difference between the Mineral Rent(as % of GDP) of South Asia in 1992 and the Mineral Rent(as % of GDP) of Korea (Republic) in 1994?
Your answer should be very brief. 0.23. What is the difference between the Mineral Rent(as % of GDP) in Middle East & North Africa (all income levels) in 1992 and the Mineral Rent(as % of GDP) in Other small states in 1995?
Your answer should be compact. -0.2. What is the difference between the Mineral Rent(as % of GDP) in Middle East & North Africa (all income levels) in 1992 and the Mineral Rent(as % of GDP) in South Asia in 1995?
Your answer should be very brief. -0.11. What is the difference between the Mineral Rent(as % of GDP) of Middle East & North Africa (all income levels) in 1992 and the Mineral Rent(as % of GDP) of Korea (Republic) in 1995?
Your answer should be very brief. 0.03. What is the difference between the Mineral Rent(as % of GDP) of Other small states in 1992 and the Mineral Rent(as % of GDP) of South Asia in 1995?
Offer a terse response. 0.09. What is the difference between the Mineral Rent(as % of GDP) of Other small states in 1992 and the Mineral Rent(as % of GDP) of Korea (Republic) in 1995?
Make the answer very short. 0.23. What is the difference between the Mineral Rent(as % of GDP) of South Asia in 1992 and the Mineral Rent(as % of GDP) of Korea (Republic) in 1995?
Offer a terse response. 0.23. What is the difference between the Mineral Rent(as % of GDP) in Middle East & North Africa (all income levels) in 1992 and the Mineral Rent(as % of GDP) in Other small states in 1996?
Provide a succinct answer. -0.07. What is the difference between the Mineral Rent(as % of GDP) in Middle East & North Africa (all income levels) in 1992 and the Mineral Rent(as % of GDP) in South Asia in 1996?
Offer a terse response. -0.12. What is the difference between the Mineral Rent(as % of GDP) in Middle East & North Africa (all income levels) in 1992 and the Mineral Rent(as % of GDP) in Korea (Republic) in 1996?
Make the answer very short. 0.03. What is the difference between the Mineral Rent(as % of GDP) in Other small states in 1992 and the Mineral Rent(as % of GDP) in South Asia in 1996?
Provide a short and direct response. 0.07. What is the difference between the Mineral Rent(as % of GDP) of Other small states in 1992 and the Mineral Rent(as % of GDP) of Korea (Republic) in 1996?
Your answer should be compact. 0.23. What is the difference between the Mineral Rent(as % of GDP) in South Asia in 1992 and the Mineral Rent(as % of GDP) in Korea (Republic) in 1996?
Your response must be concise. 0.22. What is the difference between the Mineral Rent(as % of GDP) of Middle East & North Africa (all income levels) in 1992 and the Mineral Rent(as % of GDP) of Other small states in 1997?
Make the answer very short. -0.12. What is the difference between the Mineral Rent(as % of GDP) in Middle East & North Africa (all income levels) in 1992 and the Mineral Rent(as % of GDP) in South Asia in 1997?
Your response must be concise. -0.12. What is the difference between the Mineral Rent(as % of GDP) of Middle East & North Africa (all income levels) in 1992 and the Mineral Rent(as % of GDP) of Korea (Republic) in 1997?
Your answer should be compact. 0.03. What is the difference between the Mineral Rent(as % of GDP) of Other small states in 1992 and the Mineral Rent(as % of GDP) of South Asia in 1997?
Offer a very short reply. 0.07. What is the difference between the Mineral Rent(as % of GDP) in Other small states in 1992 and the Mineral Rent(as % of GDP) in Korea (Republic) in 1997?
Offer a terse response. 0.23. What is the difference between the Mineral Rent(as % of GDP) of South Asia in 1992 and the Mineral Rent(as % of GDP) of Korea (Republic) in 1997?
Your response must be concise. 0.23. What is the difference between the Mineral Rent(as % of GDP) in Middle East & North Africa (all income levels) in 1993 and the Mineral Rent(as % of GDP) in Other small states in 1994?
Offer a terse response. -0.17. What is the difference between the Mineral Rent(as % of GDP) of Middle East & North Africa (all income levels) in 1993 and the Mineral Rent(as % of GDP) of South Asia in 1994?
Your response must be concise. -0.13. What is the difference between the Mineral Rent(as % of GDP) of Middle East & North Africa (all income levels) in 1993 and the Mineral Rent(as % of GDP) of Korea (Republic) in 1994?
Your answer should be very brief. 0.02. What is the difference between the Mineral Rent(as % of GDP) in Other small states in 1993 and the Mineral Rent(as % of GDP) in South Asia in 1994?
Offer a very short reply. -0.06. What is the difference between the Mineral Rent(as % of GDP) of Other small states in 1993 and the Mineral Rent(as % of GDP) of Korea (Republic) in 1994?
Provide a short and direct response. 0.09. What is the difference between the Mineral Rent(as % of GDP) of South Asia in 1993 and the Mineral Rent(as % of GDP) of Korea (Republic) in 1994?
Your answer should be compact. 0.19. What is the difference between the Mineral Rent(as % of GDP) in Middle East & North Africa (all income levels) in 1993 and the Mineral Rent(as % of GDP) in Other small states in 1995?
Provide a succinct answer. -0.22. What is the difference between the Mineral Rent(as % of GDP) of Middle East & North Africa (all income levels) in 1993 and the Mineral Rent(as % of GDP) of South Asia in 1995?
Provide a succinct answer. -0.13. What is the difference between the Mineral Rent(as % of GDP) in Middle East & North Africa (all income levels) in 1993 and the Mineral Rent(as % of GDP) in Korea (Republic) in 1995?
Your response must be concise. 0.01. What is the difference between the Mineral Rent(as % of GDP) of Other small states in 1993 and the Mineral Rent(as % of GDP) of South Asia in 1995?
Your answer should be compact. -0.06. What is the difference between the Mineral Rent(as % of GDP) of Other small states in 1993 and the Mineral Rent(as % of GDP) of Korea (Republic) in 1995?
Your answer should be very brief. 0.09. What is the difference between the Mineral Rent(as % of GDP) of South Asia in 1993 and the Mineral Rent(as % of GDP) of Korea (Republic) in 1995?
Your answer should be compact. 0.19. What is the difference between the Mineral Rent(as % of GDP) of Middle East & North Africa (all income levels) in 1993 and the Mineral Rent(as % of GDP) of Other small states in 1996?
Offer a very short reply. -0.09. What is the difference between the Mineral Rent(as % of GDP) in Middle East & North Africa (all income levels) in 1993 and the Mineral Rent(as % of GDP) in South Asia in 1996?
Keep it short and to the point. -0.14. What is the difference between the Mineral Rent(as % of GDP) of Middle East & North Africa (all income levels) in 1993 and the Mineral Rent(as % of GDP) of Korea (Republic) in 1996?
Make the answer very short. 0.01. What is the difference between the Mineral Rent(as % of GDP) of Other small states in 1993 and the Mineral Rent(as % of GDP) of South Asia in 1996?
Your response must be concise. -0.07. What is the difference between the Mineral Rent(as % of GDP) in Other small states in 1993 and the Mineral Rent(as % of GDP) in Korea (Republic) in 1996?
Offer a very short reply. 0.08. What is the difference between the Mineral Rent(as % of GDP) of South Asia in 1993 and the Mineral Rent(as % of GDP) of Korea (Republic) in 1996?
Ensure brevity in your answer.  0.19. What is the difference between the Mineral Rent(as % of GDP) of Middle East & North Africa (all income levels) in 1993 and the Mineral Rent(as % of GDP) of Other small states in 1997?
Offer a terse response. -0.14. What is the difference between the Mineral Rent(as % of GDP) in Middle East & North Africa (all income levels) in 1993 and the Mineral Rent(as % of GDP) in South Asia in 1997?
Your answer should be compact. -0.14. What is the difference between the Mineral Rent(as % of GDP) in Middle East & North Africa (all income levels) in 1993 and the Mineral Rent(as % of GDP) in Korea (Republic) in 1997?
Your answer should be very brief. 0.02. What is the difference between the Mineral Rent(as % of GDP) of Other small states in 1993 and the Mineral Rent(as % of GDP) of South Asia in 1997?
Your answer should be compact. -0.07. What is the difference between the Mineral Rent(as % of GDP) in Other small states in 1993 and the Mineral Rent(as % of GDP) in Korea (Republic) in 1997?
Offer a very short reply. 0.09. What is the difference between the Mineral Rent(as % of GDP) of South Asia in 1993 and the Mineral Rent(as % of GDP) of Korea (Republic) in 1997?
Offer a terse response. 0.19. What is the difference between the Mineral Rent(as % of GDP) of Middle East & North Africa (all income levels) in 1994 and the Mineral Rent(as % of GDP) of Other small states in 1995?
Offer a very short reply. -0.2. What is the difference between the Mineral Rent(as % of GDP) in Middle East & North Africa (all income levels) in 1994 and the Mineral Rent(as % of GDP) in South Asia in 1995?
Give a very brief answer. -0.12. What is the difference between the Mineral Rent(as % of GDP) of Middle East & North Africa (all income levels) in 1994 and the Mineral Rent(as % of GDP) of Korea (Republic) in 1995?
Your answer should be very brief. 0.02. What is the difference between the Mineral Rent(as % of GDP) in Other small states in 1994 and the Mineral Rent(as % of GDP) in South Asia in 1995?
Make the answer very short. 0.04. What is the difference between the Mineral Rent(as % of GDP) in Other small states in 1994 and the Mineral Rent(as % of GDP) in Korea (Republic) in 1995?
Provide a succinct answer. 0.18. What is the difference between the Mineral Rent(as % of GDP) of South Asia in 1994 and the Mineral Rent(as % of GDP) of Korea (Republic) in 1995?
Keep it short and to the point. 0.14. What is the difference between the Mineral Rent(as % of GDP) in Middle East & North Africa (all income levels) in 1994 and the Mineral Rent(as % of GDP) in Other small states in 1996?
Provide a succinct answer. -0.08. What is the difference between the Mineral Rent(as % of GDP) of Middle East & North Africa (all income levels) in 1994 and the Mineral Rent(as % of GDP) of South Asia in 1996?
Your answer should be compact. -0.13. What is the difference between the Mineral Rent(as % of GDP) of Middle East & North Africa (all income levels) in 1994 and the Mineral Rent(as % of GDP) of Korea (Republic) in 1996?
Your response must be concise. 0.02. What is the difference between the Mineral Rent(as % of GDP) of Other small states in 1994 and the Mineral Rent(as % of GDP) of South Asia in 1996?
Give a very brief answer. 0.03. What is the difference between the Mineral Rent(as % of GDP) of Other small states in 1994 and the Mineral Rent(as % of GDP) of Korea (Republic) in 1996?
Keep it short and to the point. 0.18. What is the difference between the Mineral Rent(as % of GDP) in South Asia in 1994 and the Mineral Rent(as % of GDP) in Korea (Republic) in 1996?
Offer a terse response. 0.14. What is the difference between the Mineral Rent(as % of GDP) of Middle East & North Africa (all income levels) in 1994 and the Mineral Rent(as % of GDP) of Other small states in 1997?
Give a very brief answer. -0.13. What is the difference between the Mineral Rent(as % of GDP) in Middle East & North Africa (all income levels) in 1994 and the Mineral Rent(as % of GDP) in South Asia in 1997?
Offer a very short reply. -0.13. What is the difference between the Mineral Rent(as % of GDP) in Middle East & North Africa (all income levels) in 1994 and the Mineral Rent(as % of GDP) in Korea (Republic) in 1997?
Your answer should be compact. 0.03. What is the difference between the Mineral Rent(as % of GDP) in Other small states in 1994 and the Mineral Rent(as % of GDP) in South Asia in 1997?
Offer a very short reply. 0.03. What is the difference between the Mineral Rent(as % of GDP) in Other small states in 1994 and the Mineral Rent(as % of GDP) in Korea (Republic) in 1997?
Offer a very short reply. 0.18. What is the difference between the Mineral Rent(as % of GDP) in South Asia in 1994 and the Mineral Rent(as % of GDP) in Korea (Republic) in 1997?
Give a very brief answer. 0.15. What is the difference between the Mineral Rent(as % of GDP) in Middle East & North Africa (all income levels) in 1995 and the Mineral Rent(as % of GDP) in Other small states in 1996?
Give a very brief answer. -0.08. What is the difference between the Mineral Rent(as % of GDP) in Middle East & North Africa (all income levels) in 1995 and the Mineral Rent(as % of GDP) in South Asia in 1996?
Ensure brevity in your answer.  -0.13. What is the difference between the Mineral Rent(as % of GDP) in Middle East & North Africa (all income levels) in 1995 and the Mineral Rent(as % of GDP) in Korea (Republic) in 1996?
Provide a short and direct response. 0.03. What is the difference between the Mineral Rent(as % of GDP) of Other small states in 1995 and the Mineral Rent(as % of GDP) of South Asia in 1996?
Offer a very short reply. 0.08. What is the difference between the Mineral Rent(as % of GDP) of Other small states in 1995 and the Mineral Rent(as % of GDP) of Korea (Republic) in 1996?
Offer a very short reply. 0.23. What is the difference between the Mineral Rent(as % of GDP) in South Asia in 1995 and the Mineral Rent(as % of GDP) in Korea (Republic) in 1996?
Offer a very short reply. 0.14. What is the difference between the Mineral Rent(as % of GDP) in Middle East & North Africa (all income levels) in 1995 and the Mineral Rent(as % of GDP) in Other small states in 1997?
Your answer should be compact. -0.13. What is the difference between the Mineral Rent(as % of GDP) in Middle East & North Africa (all income levels) in 1995 and the Mineral Rent(as % of GDP) in South Asia in 1997?
Your answer should be very brief. -0.13. What is the difference between the Mineral Rent(as % of GDP) in Middle East & North Africa (all income levels) in 1995 and the Mineral Rent(as % of GDP) in Korea (Republic) in 1997?
Your response must be concise. 0.03. What is the difference between the Mineral Rent(as % of GDP) of Other small states in 1995 and the Mineral Rent(as % of GDP) of South Asia in 1997?
Make the answer very short. 0.07. What is the difference between the Mineral Rent(as % of GDP) in Other small states in 1995 and the Mineral Rent(as % of GDP) in Korea (Republic) in 1997?
Keep it short and to the point. 0.23. What is the difference between the Mineral Rent(as % of GDP) in South Asia in 1995 and the Mineral Rent(as % of GDP) in Korea (Republic) in 1997?
Your answer should be very brief. 0.14. What is the difference between the Mineral Rent(as % of GDP) in Middle East & North Africa (all income levels) in 1996 and the Mineral Rent(as % of GDP) in Other small states in 1997?
Your answer should be compact. -0.14. What is the difference between the Mineral Rent(as % of GDP) in Middle East & North Africa (all income levels) in 1996 and the Mineral Rent(as % of GDP) in South Asia in 1997?
Your answer should be compact. -0.14. What is the difference between the Mineral Rent(as % of GDP) in Middle East & North Africa (all income levels) in 1996 and the Mineral Rent(as % of GDP) in Korea (Republic) in 1997?
Provide a succinct answer. 0.02. What is the difference between the Mineral Rent(as % of GDP) of Other small states in 1996 and the Mineral Rent(as % of GDP) of South Asia in 1997?
Keep it short and to the point. -0.05. What is the difference between the Mineral Rent(as % of GDP) in Other small states in 1996 and the Mineral Rent(as % of GDP) in Korea (Republic) in 1997?
Provide a succinct answer. 0.11. What is the difference between the Mineral Rent(as % of GDP) in South Asia in 1996 and the Mineral Rent(as % of GDP) in Korea (Republic) in 1997?
Your response must be concise. 0.15. What is the average Mineral Rent(as % of GDP) of Middle East & North Africa (all income levels) per year?
Make the answer very short. 0.03. What is the average Mineral Rent(as % of GDP) of Other small states per year?
Provide a succinct answer. 0.37. What is the average Mineral Rent(as % of GDP) in South Asia per year?
Provide a succinct answer. 0.19. What is the average Mineral Rent(as % of GDP) of Korea (Republic) per year?
Make the answer very short. 0. In the year 1990, what is the difference between the Mineral Rent(as % of GDP) of Middle East & North Africa (all income levels) and Mineral Rent(as % of GDP) of Other small states?
Provide a short and direct response. -1.63. In the year 1990, what is the difference between the Mineral Rent(as % of GDP) of Middle East & North Africa (all income levels) and Mineral Rent(as % of GDP) of South Asia?
Make the answer very short. -0.19. In the year 1990, what is the difference between the Mineral Rent(as % of GDP) of Middle East & North Africa (all income levels) and Mineral Rent(as % of GDP) of Korea (Republic)?
Offer a very short reply. 0.02. In the year 1990, what is the difference between the Mineral Rent(as % of GDP) of Other small states and Mineral Rent(as % of GDP) of South Asia?
Give a very brief answer. 1.44. In the year 1990, what is the difference between the Mineral Rent(as % of GDP) of Other small states and Mineral Rent(as % of GDP) of Korea (Republic)?
Offer a very short reply. 1.65. In the year 1990, what is the difference between the Mineral Rent(as % of GDP) in South Asia and Mineral Rent(as % of GDP) in Korea (Republic)?
Your answer should be compact. 0.21. In the year 1991, what is the difference between the Mineral Rent(as % of GDP) of Middle East & North Africa (all income levels) and Mineral Rent(as % of GDP) of Other small states?
Provide a short and direct response. -0.29. In the year 1991, what is the difference between the Mineral Rent(as % of GDP) of Middle East & North Africa (all income levels) and Mineral Rent(as % of GDP) of South Asia?
Provide a short and direct response. -0.23. In the year 1991, what is the difference between the Mineral Rent(as % of GDP) of Middle East & North Africa (all income levels) and Mineral Rent(as % of GDP) of Korea (Republic)?
Provide a short and direct response. 0.04. In the year 1991, what is the difference between the Mineral Rent(as % of GDP) in Other small states and Mineral Rent(as % of GDP) in South Asia?
Provide a short and direct response. 0.06. In the year 1991, what is the difference between the Mineral Rent(as % of GDP) in Other small states and Mineral Rent(as % of GDP) in Korea (Republic)?
Your answer should be compact. 0.33. In the year 1991, what is the difference between the Mineral Rent(as % of GDP) in South Asia and Mineral Rent(as % of GDP) in Korea (Republic)?
Your answer should be very brief. 0.27. In the year 1992, what is the difference between the Mineral Rent(as % of GDP) in Middle East & North Africa (all income levels) and Mineral Rent(as % of GDP) in Other small states?
Make the answer very short. -0.2. In the year 1992, what is the difference between the Mineral Rent(as % of GDP) of Middle East & North Africa (all income levels) and Mineral Rent(as % of GDP) of South Asia?
Your answer should be compact. -0.19. In the year 1992, what is the difference between the Mineral Rent(as % of GDP) of Middle East & North Africa (all income levels) and Mineral Rent(as % of GDP) of Korea (Republic)?
Offer a terse response. 0.03. In the year 1992, what is the difference between the Mineral Rent(as % of GDP) of Other small states and Mineral Rent(as % of GDP) of South Asia?
Your answer should be very brief. 0. In the year 1992, what is the difference between the Mineral Rent(as % of GDP) of Other small states and Mineral Rent(as % of GDP) of Korea (Republic)?
Make the answer very short. 0.23. In the year 1992, what is the difference between the Mineral Rent(as % of GDP) in South Asia and Mineral Rent(as % of GDP) in Korea (Republic)?
Offer a very short reply. 0.23. In the year 1993, what is the difference between the Mineral Rent(as % of GDP) of Middle East & North Africa (all income levels) and Mineral Rent(as % of GDP) of Other small states?
Offer a terse response. -0.07. In the year 1993, what is the difference between the Mineral Rent(as % of GDP) of Middle East & North Africa (all income levels) and Mineral Rent(as % of GDP) of South Asia?
Provide a short and direct response. -0.17. In the year 1993, what is the difference between the Mineral Rent(as % of GDP) in Middle East & North Africa (all income levels) and Mineral Rent(as % of GDP) in Korea (Republic)?
Provide a short and direct response. 0.02. In the year 1993, what is the difference between the Mineral Rent(as % of GDP) in Other small states and Mineral Rent(as % of GDP) in South Asia?
Provide a succinct answer. -0.1. In the year 1993, what is the difference between the Mineral Rent(as % of GDP) in Other small states and Mineral Rent(as % of GDP) in Korea (Republic)?
Offer a terse response. 0.09. In the year 1993, what is the difference between the Mineral Rent(as % of GDP) in South Asia and Mineral Rent(as % of GDP) in Korea (Republic)?
Ensure brevity in your answer.  0.19. In the year 1994, what is the difference between the Mineral Rent(as % of GDP) in Middle East & North Africa (all income levels) and Mineral Rent(as % of GDP) in Other small states?
Make the answer very short. -0.16. In the year 1994, what is the difference between the Mineral Rent(as % of GDP) of Middle East & North Africa (all income levels) and Mineral Rent(as % of GDP) of South Asia?
Your response must be concise. -0.12. In the year 1994, what is the difference between the Mineral Rent(as % of GDP) of Middle East & North Africa (all income levels) and Mineral Rent(as % of GDP) of Korea (Republic)?
Your answer should be very brief. 0.03. In the year 1994, what is the difference between the Mineral Rent(as % of GDP) of Other small states and Mineral Rent(as % of GDP) of South Asia?
Keep it short and to the point. 0.04. In the year 1994, what is the difference between the Mineral Rent(as % of GDP) in Other small states and Mineral Rent(as % of GDP) in Korea (Republic)?
Offer a terse response. 0.18. In the year 1994, what is the difference between the Mineral Rent(as % of GDP) of South Asia and Mineral Rent(as % of GDP) of Korea (Republic)?
Keep it short and to the point. 0.15. In the year 1995, what is the difference between the Mineral Rent(as % of GDP) in Middle East & North Africa (all income levels) and Mineral Rent(as % of GDP) in Other small states?
Give a very brief answer. -0.2. In the year 1995, what is the difference between the Mineral Rent(as % of GDP) of Middle East & North Africa (all income levels) and Mineral Rent(as % of GDP) of South Asia?
Ensure brevity in your answer.  -0.12. In the year 1995, what is the difference between the Mineral Rent(as % of GDP) in Middle East & North Africa (all income levels) and Mineral Rent(as % of GDP) in Korea (Republic)?
Make the answer very short. 0.03. In the year 1995, what is the difference between the Mineral Rent(as % of GDP) of Other small states and Mineral Rent(as % of GDP) of South Asia?
Make the answer very short. 0.09. In the year 1995, what is the difference between the Mineral Rent(as % of GDP) of Other small states and Mineral Rent(as % of GDP) of Korea (Republic)?
Your response must be concise. 0.23. In the year 1995, what is the difference between the Mineral Rent(as % of GDP) of South Asia and Mineral Rent(as % of GDP) of Korea (Republic)?
Provide a succinct answer. 0.14. In the year 1996, what is the difference between the Mineral Rent(as % of GDP) in Middle East & North Africa (all income levels) and Mineral Rent(as % of GDP) in Other small states?
Give a very brief answer. -0.09. In the year 1996, what is the difference between the Mineral Rent(as % of GDP) of Middle East & North Africa (all income levels) and Mineral Rent(as % of GDP) of South Asia?
Your response must be concise. -0.14. In the year 1996, what is the difference between the Mineral Rent(as % of GDP) of Middle East & North Africa (all income levels) and Mineral Rent(as % of GDP) of Korea (Republic)?
Offer a very short reply. 0.01. In the year 1996, what is the difference between the Mineral Rent(as % of GDP) in Other small states and Mineral Rent(as % of GDP) in South Asia?
Offer a very short reply. -0.05. In the year 1996, what is the difference between the Mineral Rent(as % of GDP) in Other small states and Mineral Rent(as % of GDP) in Korea (Republic)?
Provide a short and direct response. 0.1. In the year 1996, what is the difference between the Mineral Rent(as % of GDP) of South Asia and Mineral Rent(as % of GDP) of Korea (Republic)?
Make the answer very short. 0.15. In the year 1997, what is the difference between the Mineral Rent(as % of GDP) of Middle East & North Africa (all income levels) and Mineral Rent(as % of GDP) of Other small states?
Keep it short and to the point. -0.12. In the year 1997, what is the difference between the Mineral Rent(as % of GDP) of Middle East & North Africa (all income levels) and Mineral Rent(as % of GDP) of South Asia?
Your answer should be compact. -0.12. In the year 1997, what is the difference between the Mineral Rent(as % of GDP) of Middle East & North Africa (all income levels) and Mineral Rent(as % of GDP) of Korea (Republic)?
Provide a succinct answer. 0.03. In the year 1997, what is the difference between the Mineral Rent(as % of GDP) in Other small states and Mineral Rent(as % of GDP) in South Asia?
Your answer should be very brief. -0. In the year 1997, what is the difference between the Mineral Rent(as % of GDP) of Other small states and Mineral Rent(as % of GDP) of Korea (Republic)?
Offer a very short reply. 0.15. In the year 1997, what is the difference between the Mineral Rent(as % of GDP) in South Asia and Mineral Rent(as % of GDP) in Korea (Republic)?
Ensure brevity in your answer.  0.16. What is the ratio of the Mineral Rent(as % of GDP) in Middle East & North Africa (all income levels) in 1990 to that in 1991?
Offer a terse response. 1.06. What is the ratio of the Mineral Rent(as % of GDP) in Other small states in 1990 to that in 1991?
Offer a very short reply. 5.06. What is the ratio of the Mineral Rent(as % of GDP) in South Asia in 1990 to that in 1991?
Your answer should be very brief. 0.88. What is the ratio of the Mineral Rent(as % of GDP) in Korea (Republic) in 1990 to that in 1991?
Make the answer very short. 28.92. What is the ratio of the Mineral Rent(as % of GDP) of Middle East & North Africa (all income levels) in 1990 to that in 1992?
Make the answer very short. 1.29. What is the ratio of the Mineral Rent(as % of GDP) in Other small states in 1990 to that in 1992?
Your answer should be very brief. 7.28. What is the ratio of the Mineral Rent(as % of GDP) of South Asia in 1990 to that in 1992?
Ensure brevity in your answer.  1.05. What is the ratio of the Mineral Rent(as % of GDP) in Korea (Republic) in 1990 to that in 1992?
Provide a succinct answer. 49.34. What is the ratio of the Mineral Rent(as % of GDP) in Middle East & North Africa (all income levels) in 1990 to that in 1993?
Offer a terse response. 2.83. What is the ratio of the Mineral Rent(as % of GDP) of Other small states in 1990 to that in 1993?
Offer a very short reply. 19.02. What is the ratio of the Mineral Rent(as % of GDP) in South Asia in 1990 to that in 1993?
Provide a short and direct response. 1.25. What is the ratio of the Mineral Rent(as % of GDP) of Korea (Republic) in 1990 to that in 1993?
Keep it short and to the point. 155.37. What is the ratio of the Mineral Rent(as % of GDP) of Middle East & North Africa (all income levels) in 1990 to that in 1994?
Offer a terse response. 1.65. What is the ratio of the Mineral Rent(as % of GDP) in Other small states in 1990 to that in 1994?
Your answer should be compact. 9.09. What is the ratio of the Mineral Rent(as % of GDP) of South Asia in 1990 to that in 1994?
Provide a short and direct response. 1.64. What is the ratio of the Mineral Rent(as % of GDP) of Korea (Republic) in 1990 to that in 1994?
Your response must be concise. 36.99. What is the ratio of the Mineral Rent(as % of GDP) in Middle East & North Africa (all income levels) in 1990 to that in 1995?
Provide a succinct answer. 1.52. What is the ratio of the Mineral Rent(as % of GDP) in Other small states in 1990 to that in 1995?
Your answer should be compact. 7.23. What is the ratio of the Mineral Rent(as % of GDP) of South Asia in 1990 to that in 1995?
Your response must be concise. 1.65. What is the ratio of the Mineral Rent(as % of GDP) in Korea (Republic) in 1990 to that in 1995?
Provide a succinct answer. 8.95. What is the ratio of the Mineral Rent(as % of GDP) of Middle East & North Africa (all income levels) in 1990 to that in 1996?
Provide a short and direct response. 2.43. What is the ratio of the Mineral Rent(as % of GDP) of Other small states in 1990 to that in 1996?
Keep it short and to the point. 15.83. What is the ratio of the Mineral Rent(as % of GDP) in South Asia in 1990 to that in 1996?
Offer a terse response. 1.53. What is the ratio of the Mineral Rent(as % of GDP) of Korea (Republic) in 1990 to that in 1996?
Ensure brevity in your answer.  6.82. What is the ratio of the Mineral Rent(as % of GDP) in Middle East & North Africa (all income levels) in 1990 to that in 1997?
Offer a very short reply. 1.32. What is the ratio of the Mineral Rent(as % of GDP) in Other small states in 1990 to that in 1997?
Keep it short and to the point. 10.82. What is the ratio of the Mineral Rent(as % of GDP) of South Asia in 1990 to that in 1997?
Your answer should be compact. 1.52. What is the ratio of the Mineral Rent(as % of GDP) in Korea (Republic) in 1990 to that in 1997?
Ensure brevity in your answer.  61.77. What is the ratio of the Mineral Rent(as % of GDP) of Middle East & North Africa (all income levels) in 1991 to that in 1992?
Your response must be concise. 1.22. What is the ratio of the Mineral Rent(as % of GDP) of Other small states in 1991 to that in 1992?
Offer a terse response. 1.44. What is the ratio of the Mineral Rent(as % of GDP) in South Asia in 1991 to that in 1992?
Offer a very short reply. 1.19. What is the ratio of the Mineral Rent(as % of GDP) of Korea (Republic) in 1991 to that in 1992?
Ensure brevity in your answer.  1.71. What is the ratio of the Mineral Rent(as % of GDP) in Middle East & North Africa (all income levels) in 1991 to that in 1993?
Your answer should be very brief. 2.67. What is the ratio of the Mineral Rent(as % of GDP) of Other small states in 1991 to that in 1993?
Make the answer very short. 3.76. What is the ratio of the Mineral Rent(as % of GDP) of South Asia in 1991 to that in 1993?
Keep it short and to the point. 1.43. What is the ratio of the Mineral Rent(as % of GDP) of Korea (Republic) in 1991 to that in 1993?
Make the answer very short. 5.37. What is the ratio of the Mineral Rent(as % of GDP) in Middle East & North Africa (all income levels) in 1991 to that in 1994?
Offer a very short reply. 1.57. What is the ratio of the Mineral Rent(as % of GDP) of Other small states in 1991 to that in 1994?
Provide a short and direct response. 1.8. What is the ratio of the Mineral Rent(as % of GDP) of South Asia in 1991 to that in 1994?
Give a very brief answer. 1.86. What is the ratio of the Mineral Rent(as % of GDP) in Korea (Republic) in 1991 to that in 1994?
Provide a short and direct response. 1.28. What is the ratio of the Mineral Rent(as % of GDP) of Middle East & North Africa (all income levels) in 1991 to that in 1995?
Your answer should be very brief. 1.44. What is the ratio of the Mineral Rent(as % of GDP) of Other small states in 1991 to that in 1995?
Provide a succinct answer. 1.43. What is the ratio of the Mineral Rent(as % of GDP) in South Asia in 1991 to that in 1995?
Make the answer very short. 1.88. What is the ratio of the Mineral Rent(as % of GDP) in Korea (Republic) in 1991 to that in 1995?
Offer a terse response. 0.31. What is the ratio of the Mineral Rent(as % of GDP) of Middle East & North Africa (all income levels) in 1991 to that in 1996?
Offer a very short reply. 2.3. What is the ratio of the Mineral Rent(as % of GDP) in Other small states in 1991 to that in 1996?
Your response must be concise. 3.13. What is the ratio of the Mineral Rent(as % of GDP) in South Asia in 1991 to that in 1996?
Give a very brief answer. 1.75. What is the ratio of the Mineral Rent(as % of GDP) in Korea (Republic) in 1991 to that in 1996?
Your answer should be very brief. 0.24. What is the ratio of the Mineral Rent(as % of GDP) in Middle East & North Africa (all income levels) in 1991 to that in 1997?
Provide a succinct answer. 1.24. What is the ratio of the Mineral Rent(as % of GDP) in Other small states in 1991 to that in 1997?
Your answer should be very brief. 2.14. What is the ratio of the Mineral Rent(as % of GDP) of South Asia in 1991 to that in 1997?
Your response must be concise. 1.73. What is the ratio of the Mineral Rent(as % of GDP) in Korea (Republic) in 1991 to that in 1997?
Give a very brief answer. 2.14. What is the ratio of the Mineral Rent(as % of GDP) in Middle East & North Africa (all income levels) in 1992 to that in 1993?
Give a very brief answer. 2.19. What is the ratio of the Mineral Rent(as % of GDP) in Other small states in 1992 to that in 1993?
Offer a terse response. 2.61. What is the ratio of the Mineral Rent(as % of GDP) in South Asia in 1992 to that in 1993?
Ensure brevity in your answer.  1.2. What is the ratio of the Mineral Rent(as % of GDP) of Korea (Republic) in 1992 to that in 1993?
Make the answer very short. 3.15. What is the ratio of the Mineral Rent(as % of GDP) of Middle East & North Africa (all income levels) in 1992 to that in 1994?
Give a very brief answer. 1.28. What is the ratio of the Mineral Rent(as % of GDP) in Other small states in 1992 to that in 1994?
Provide a short and direct response. 1.25. What is the ratio of the Mineral Rent(as % of GDP) of South Asia in 1992 to that in 1994?
Ensure brevity in your answer.  1.56. What is the ratio of the Mineral Rent(as % of GDP) of Korea (Republic) in 1992 to that in 1994?
Offer a very short reply. 0.75. What is the ratio of the Mineral Rent(as % of GDP) in Middle East & North Africa (all income levels) in 1992 to that in 1995?
Give a very brief answer. 1.18. What is the ratio of the Mineral Rent(as % of GDP) of Other small states in 1992 to that in 1995?
Your response must be concise. 0.99. What is the ratio of the Mineral Rent(as % of GDP) of South Asia in 1992 to that in 1995?
Your answer should be compact. 1.58. What is the ratio of the Mineral Rent(as % of GDP) of Korea (Republic) in 1992 to that in 1995?
Ensure brevity in your answer.  0.18. What is the ratio of the Mineral Rent(as % of GDP) in Middle East & North Africa (all income levels) in 1992 to that in 1996?
Give a very brief answer. 1.88. What is the ratio of the Mineral Rent(as % of GDP) of Other small states in 1992 to that in 1996?
Provide a short and direct response. 2.18. What is the ratio of the Mineral Rent(as % of GDP) in South Asia in 1992 to that in 1996?
Offer a very short reply. 1.47. What is the ratio of the Mineral Rent(as % of GDP) in Korea (Republic) in 1992 to that in 1996?
Ensure brevity in your answer.  0.14. What is the ratio of the Mineral Rent(as % of GDP) in Middle East & North Africa (all income levels) in 1992 to that in 1997?
Keep it short and to the point. 1.02. What is the ratio of the Mineral Rent(as % of GDP) in Other small states in 1992 to that in 1997?
Your answer should be very brief. 1.49. What is the ratio of the Mineral Rent(as % of GDP) of South Asia in 1992 to that in 1997?
Your response must be concise. 1.45. What is the ratio of the Mineral Rent(as % of GDP) in Korea (Republic) in 1992 to that in 1997?
Provide a short and direct response. 1.25. What is the ratio of the Mineral Rent(as % of GDP) of Middle East & North Africa (all income levels) in 1993 to that in 1994?
Your response must be concise. 0.59. What is the ratio of the Mineral Rent(as % of GDP) in Other small states in 1993 to that in 1994?
Keep it short and to the point. 0.48. What is the ratio of the Mineral Rent(as % of GDP) in South Asia in 1993 to that in 1994?
Keep it short and to the point. 1.3. What is the ratio of the Mineral Rent(as % of GDP) of Korea (Republic) in 1993 to that in 1994?
Provide a short and direct response. 0.24. What is the ratio of the Mineral Rent(as % of GDP) of Middle East & North Africa (all income levels) in 1993 to that in 1995?
Your response must be concise. 0.54. What is the ratio of the Mineral Rent(as % of GDP) of Other small states in 1993 to that in 1995?
Make the answer very short. 0.38. What is the ratio of the Mineral Rent(as % of GDP) of South Asia in 1993 to that in 1995?
Your answer should be very brief. 1.31. What is the ratio of the Mineral Rent(as % of GDP) in Korea (Republic) in 1993 to that in 1995?
Provide a succinct answer. 0.06. What is the ratio of the Mineral Rent(as % of GDP) of Middle East & North Africa (all income levels) in 1993 to that in 1996?
Give a very brief answer. 0.86. What is the ratio of the Mineral Rent(as % of GDP) of Other small states in 1993 to that in 1996?
Your response must be concise. 0.83. What is the ratio of the Mineral Rent(as % of GDP) of South Asia in 1993 to that in 1996?
Your answer should be very brief. 1.22. What is the ratio of the Mineral Rent(as % of GDP) of Korea (Republic) in 1993 to that in 1996?
Ensure brevity in your answer.  0.04. What is the ratio of the Mineral Rent(as % of GDP) in Middle East & North Africa (all income levels) in 1993 to that in 1997?
Provide a short and direct response. 0.47. What is the ratio of the Mineral Rent(as % of GDP) in Other small states in 1993 to that in 1997?
Offer a terse response. 0.57. What is the ratio of the Mineral Rent(as % of GDP) in South Asia in 1993 to that in 1997?
Your answer should be very brief. 1.21. What is the ratio of the Mineral Rent(as % of GDP) of Korea (Republic) in 1993 to that in 1997?
Give a very brief answer. 0.4. What is the ratio of the Mineral Rent(as % of GDP) in Middle East & North Africa (all income levels) in 1994 to that in 1995?
Ensure brevity in your answer.  0.92. What is the ratio of the Mineral Rent(as % of GDP) in Other small states in 1994 to that in 1995?
Give a very brief answer. 0.79. What is the ratio of the Mineral Rent(as % of GDP) in Korea (Republic) in 1994 to that in 1995?
Ensure brevity in your answer.  0.24. What is the ratio of the Mineral Rent(as % of GDP) of Middle East & North Africa (all income levels) in 1994 to that in 1996?
Provide a short and direct response. 1.47. What is the ratio of the Mineral Rent(as % of GDP) of Other small states in 1994 to that in 1996?
Ensure brevity in your answer.  1.74. What is the ratio of the Mineral Rent(as % of GDP) in South Asia in 1994 to that in 1996?
Offer a very short reply. 0.94. What is the ratio of the Mineral Rent(as % of GDP) in Korea (Republic) in 1994 to that in 1996?
Make the answer very short. 0.18. What is the ratio of the Mineral Rent(as % of GDP) of Middle East & North Africa (all income levels) in 1994 to that in 1997?
Keep it short and to the point. 0.8. What is the ratio of the Mineral Rent(as % of GDP) in Other small states in 1994 to that in 1997?
Ensure brevity in your answer.  1.19. What is the ratio of the Mineral Rent(as % of GDP) in South Asia in 1994 to that in 1997?
Make the answer very short. 0.93. What is the ratio of the Mineral Rent(as % of GDP) of Korea (Republic) in 1994 to that in 1997?
Provide a succinct answer. 1.67. What is the ratio of the Mineral Rent(as % of GDP) of Middle East & North Africa (all income levels) in 1995 to that in 1996?
Offer a terse response. 1.6. What is the ratio of the Mineral Rent(as % of GDP) of Other small states in 1995 to that in 1996?
Provide a succinct answer. 2.19. What is the ratio of the Mineral Rent(as % of GDP) of South Asia in 1995 to that in 1996?
Provide a succinct answer. 0.93. What is the ratio of the Mineral Rent(as % of GDP) in Korea (Republic) in 1995 to that in 1996?
Make the answer very short. 0.76. What is the ratio of the Mineral Rent(as % of GDP) in Middle East & North Africa (all income levels) in 1995 to that in 1997?
Ensure brevity in your answer.  0.87. What is the ratio of the Mineral Rent(as % of GDP) of Other small states in 1995 to that in 1997?
Ensure brevity in your answer.  1.5. What is the ratio of the Mineral Rent(as % of GDP) in South Asia in 1995 to that in 1997?
Make the answer very short. 0.92. What is the ratio of the Mineral Rent(as % of GDP) of Korea (Republic) in 1995 to that in 1997?
Your response must be concise. 6.9. What is the ratio of the Mineral Rent(as % of GDP) of Middle East & North Africa (all income levels) in 1996 to that in 1997?
Give a very brief answer. 0.54. What is the ratio of the Mineral Rent(as % of GDP) of Other small states in 1996 to that in 1997?
Offer a very short reply. 0.68. What is the ratio of the Mineral Rent(as % of GDP) of South Asia in 1996 to that in 1997?
Make the answer very short. 0.99. What is the ratio of the Mineral Rent(as % of GDP) in Korea (Republic) in 1996 to that in 1997?
Make the answer very short. 9.05. What is the difference between the highest and the second highest Mineral Rent(as % of GDP) in Middle East & North Africa (all income levels)?
Make the answer very short. 0. What is the difference between the highest and the second highest Mineral Rent(as % of GDP) in Other small states?
Ensure brevity in your answer.  1.34. What is the difference between the highest and the second highest Mineral Rent(as % of GDP) in South Asia?
Make the answer very short. 0.03. What is the difference between the highest and the second highest Mineral Rent(as % of GDP) of Korea (Republic)?
Ensure brevity in your answer.  0.02. What is the difference between the highest and the lowest Mineral Rent(as % of GDP) of Middle East & North Africa (all income levels)?
Make the answer very short. 0.03. What is the difference between the highest and the lowest Mineral Rent(as % of GDP) in Other small states?
Provide a short and direct response. 1.59. What is the difference between the highest and the lowest Mineral Rent(as % of GDP) in South Asia?
Ensure brevity in your answer.  0.13. What is the difference between the highest and the lowest Mineral Rent(as % of GDP) in Korea (Republic)?
Your response must be concise. 0.02. 